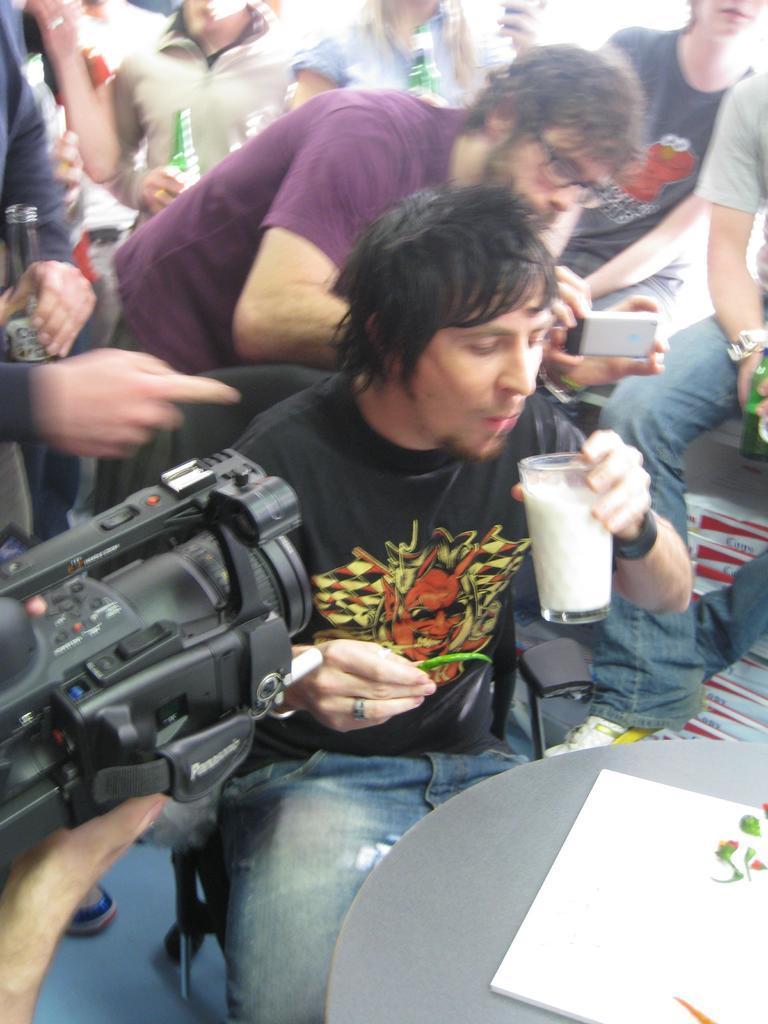Can you describe this image briefly? In the center of the image a man is sitting on a chair and holding chilli and glass which contains some liquid. In the background of the image we can see some persons and some of them are holding the bottles. On the left side of the image we can see a person is holding a camera. At the bottom of the image we can see the floor and table. On the table we can see a board. 